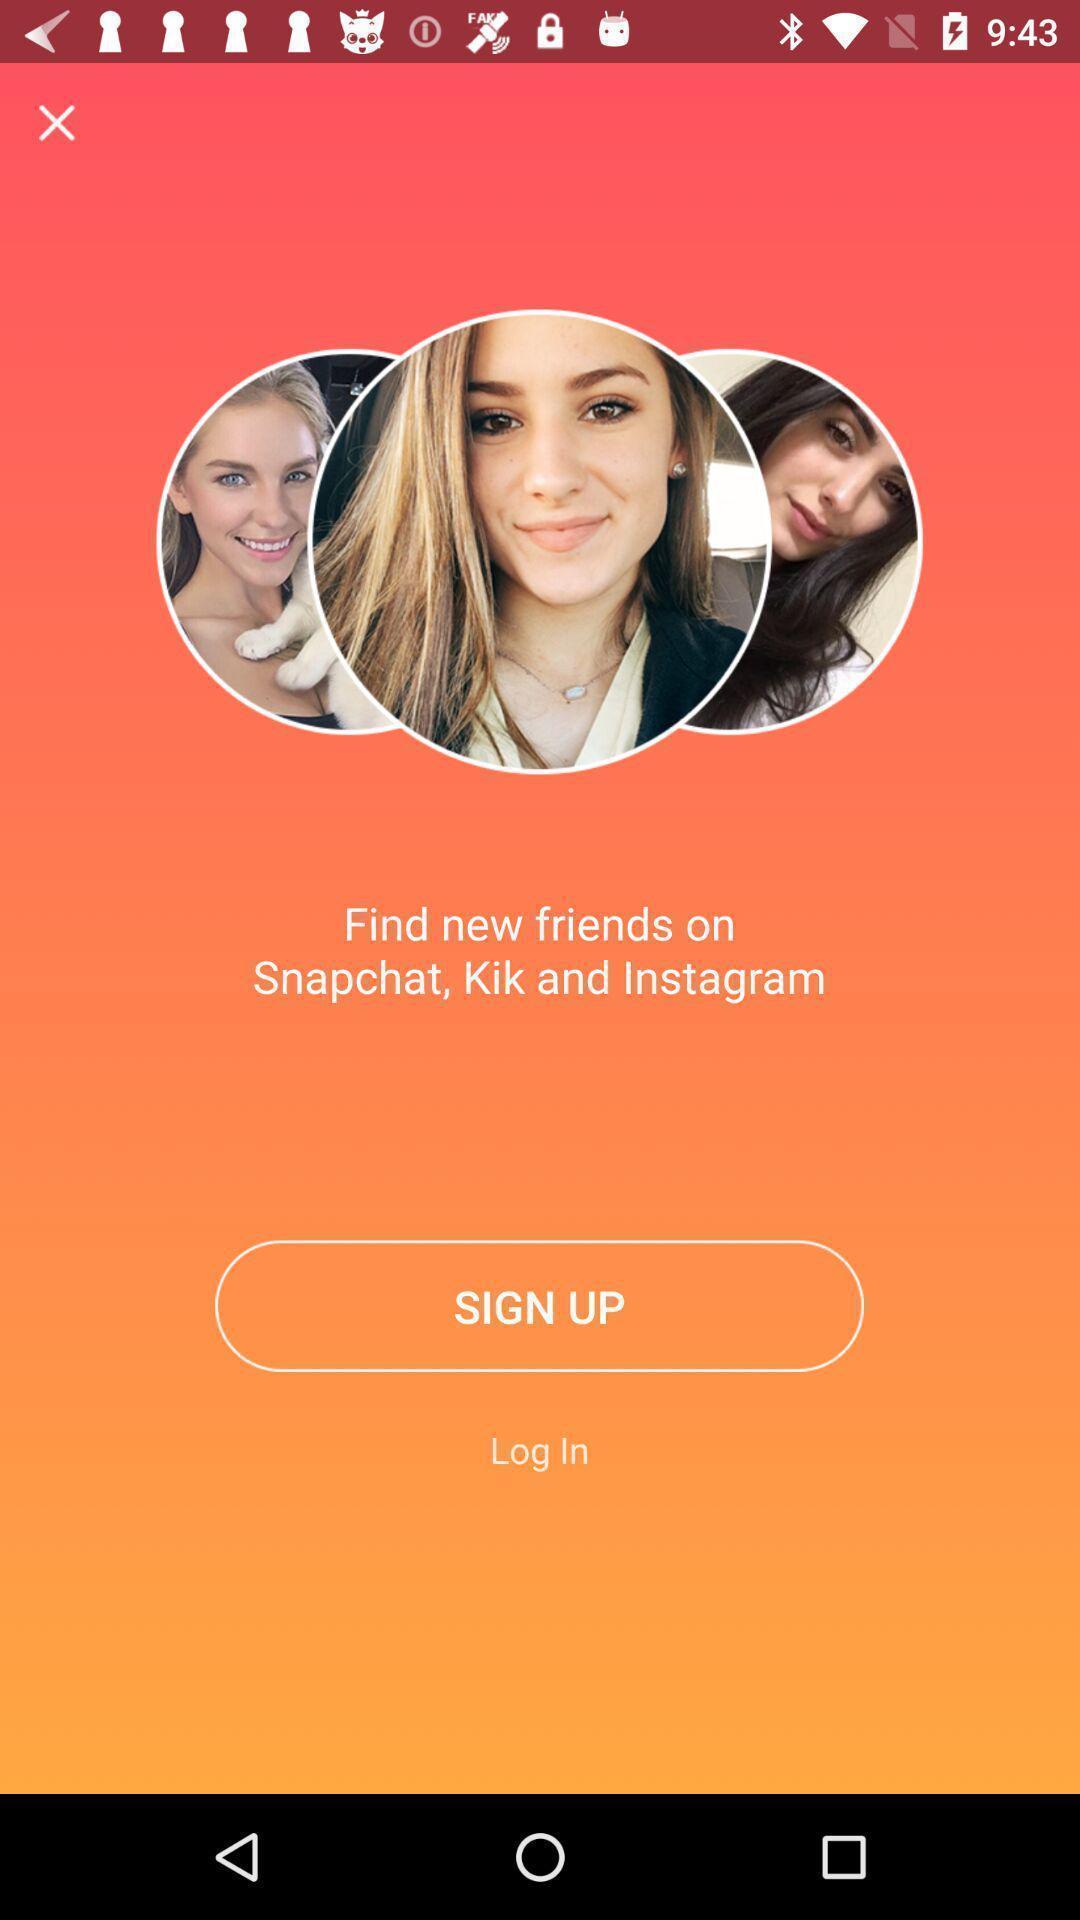Summarize the main components in this picture. Welcome page of a social networking app. 